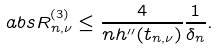<formula> <loc_0><loc_0><loc_500><loc_500>\ a b s { R _ { n , \nu } ^ { ( 3 ) } } \leq \frac { 4 } { n h ^ { \prime \prime } ( t _ { n , \nu } ) } \frac { 1 } { \delta _ { n } } .</formula> 